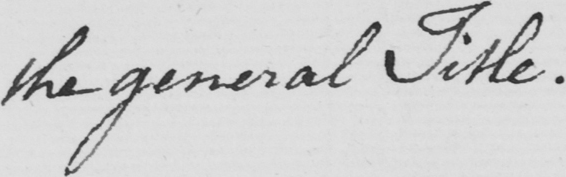Can you read and transcribe this handwriting? the general Title . 